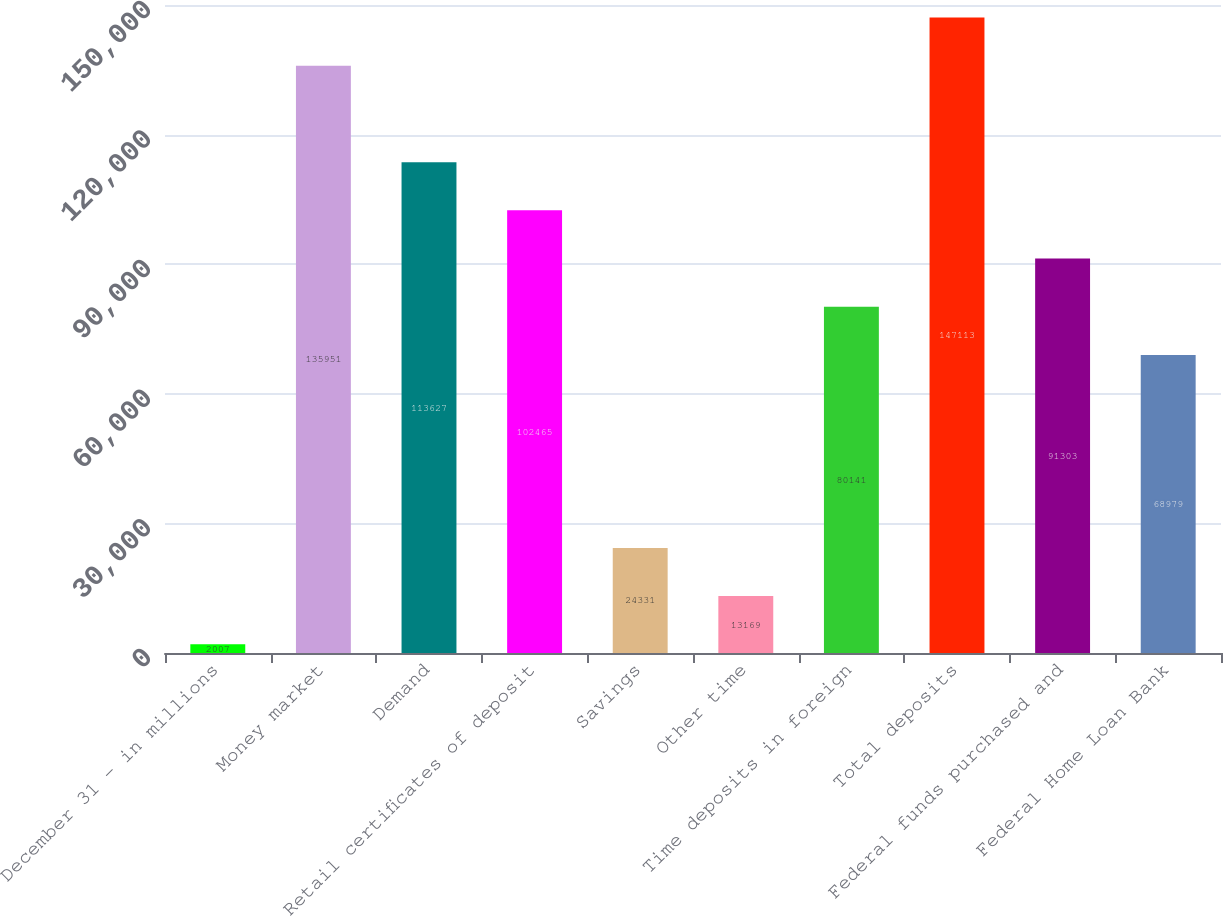<chart> <loc_0><loc_0><loc_500><loc_500><bar_chart><fcel>December 31 - in millions<fcel>Money market<fcel>Demand<fcel>Retail certificates of deposit<fcel>Savings<fcel>Other time<fcel>Time deposits in foreign<fcel>Total deposits<fcel>Federal funds purchased and<fcel>Federal Home Loan Bank<nl><fcel>2007<fcel>135951<fcel>113627<fcel>102465<fcel>24331<fcel>13169<fcel>80141<fcel>147113<fcel>91303<fcel>68979<nl></chart> 